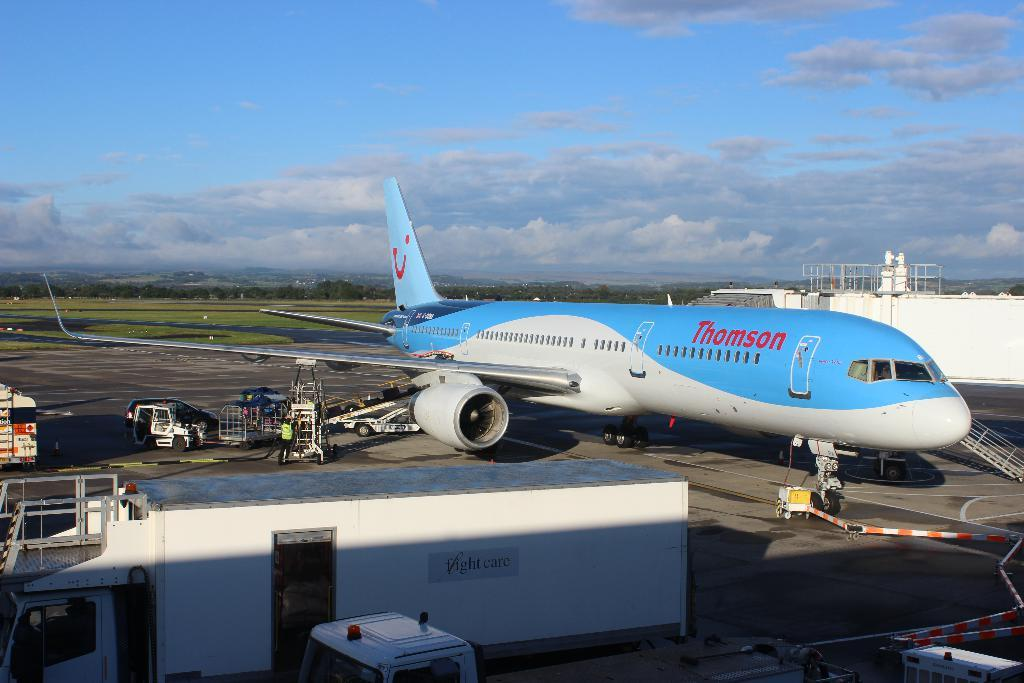<image>
Write a terse but informative summary of the picture. A blue Thomson airplane sits at the terminal getting luggage loaded 